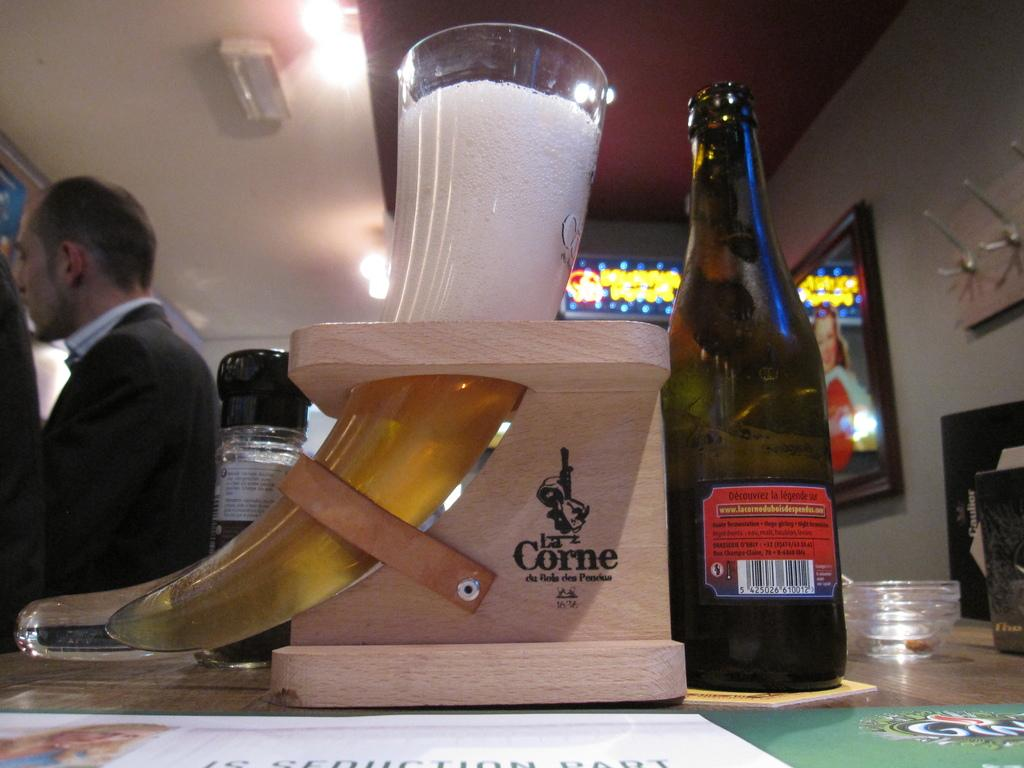What piece of furniture is in the image? There is a table in the image. What object is on the table? There is a bottle and a wooden thing (possibly a holder) on the table. What is inside the wooden thing? A glass is present in the wooden thing. Who is in the image? There is a man behind the table. What can be seen on the wall? There are frames on the wall. What type of list can be seen on the table in the image? There is no list present on the table in the image. Can you tell me how many ants are crawling on the glass in the wooden thing? There are no ants present on the glass in the wooden thing in the image. 